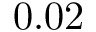<formula> <loc_0><loc_0><loc_500><loc_500>0 . 0 2</formula> 